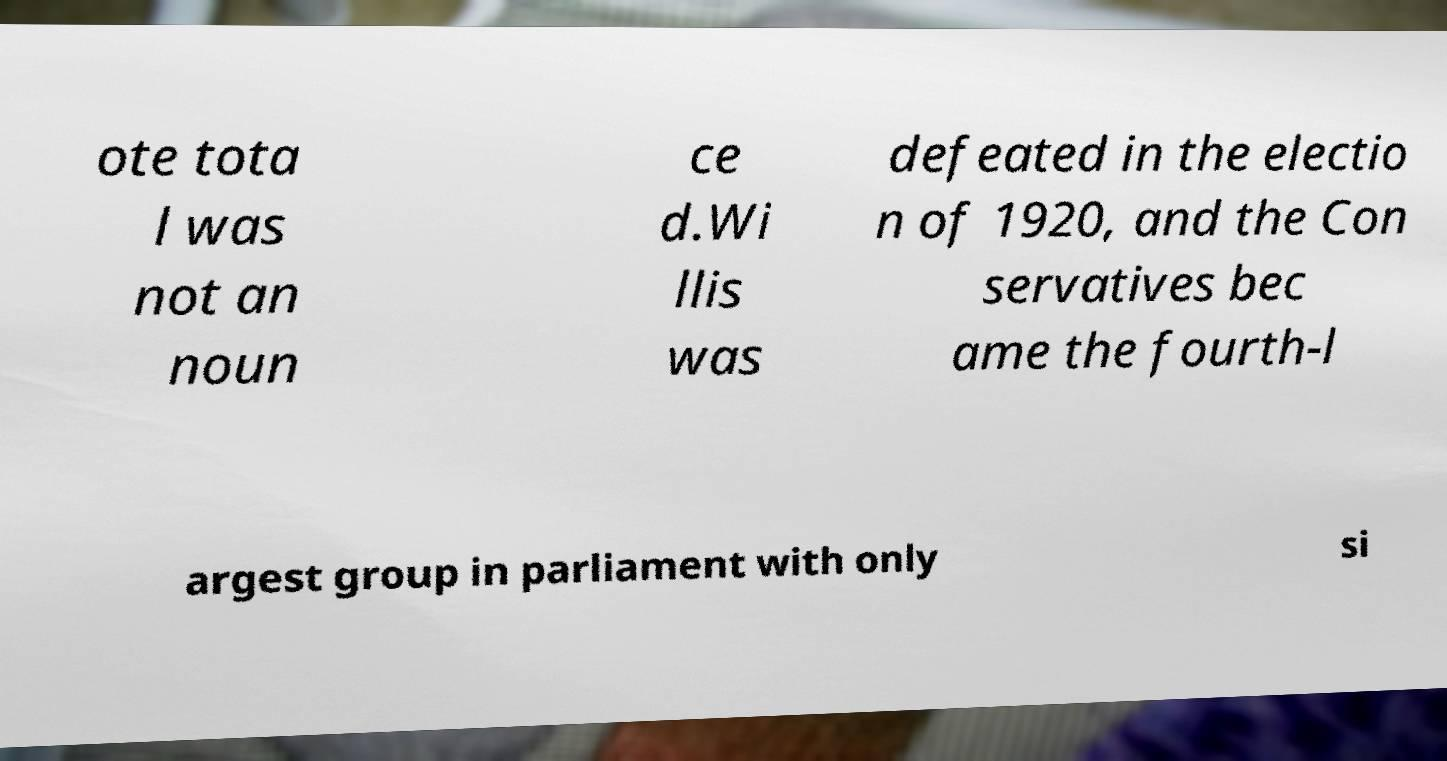Can you read and provide the text displayed in the image?This photo seems to have some interesting text. Can you extract and type it out for me? ote tota l was not an noun ce d.Wi llis was defeated in the electio n of 1920, and the Con servatives bec ame the fourth-l argest group in parliament with only si 